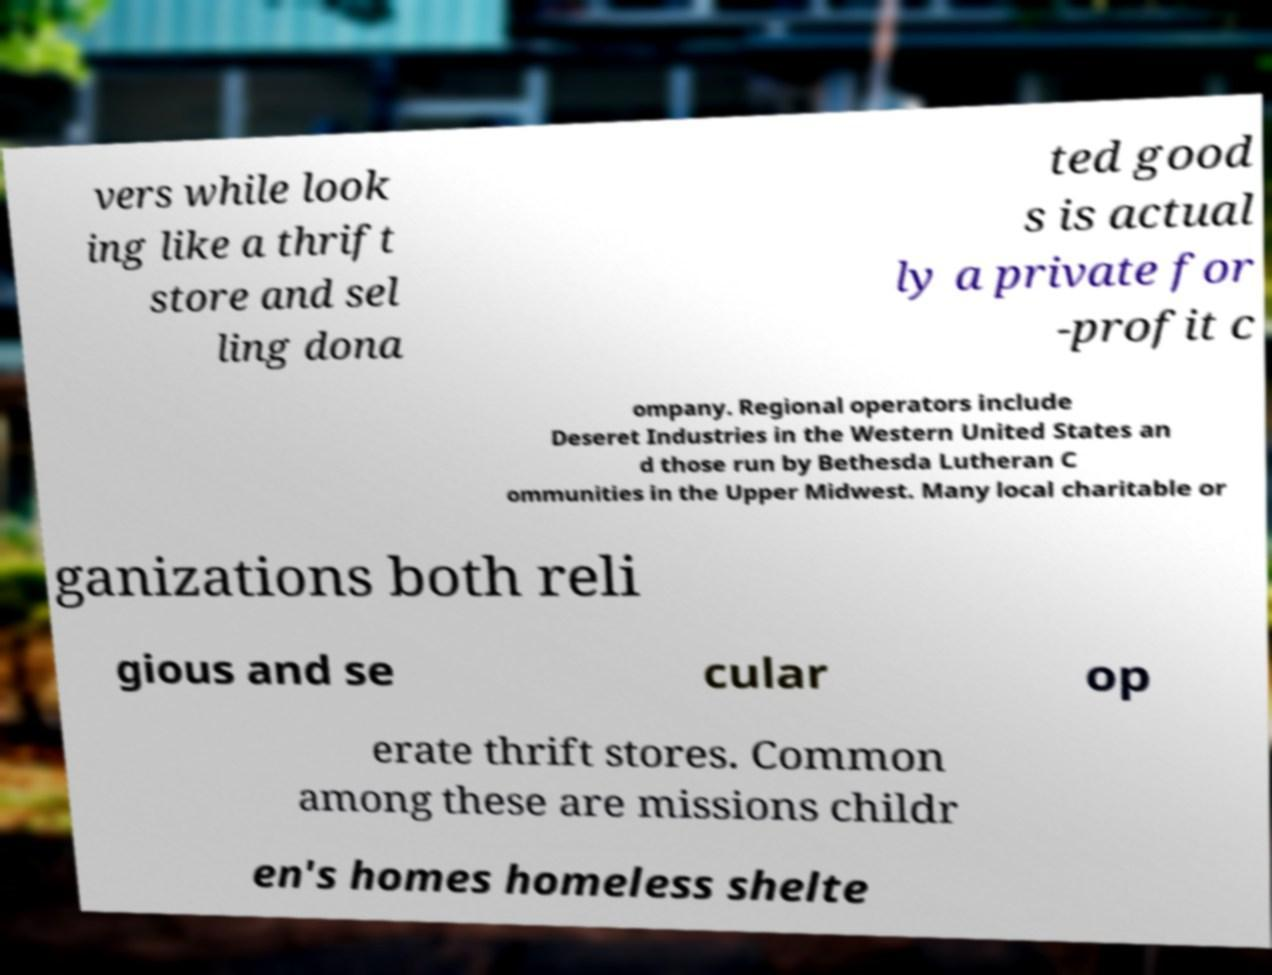For documentation purposes, I need the text within this image transcribed. Could you provide that? vers while look ing like a thrift store and sel ling dona ted good s is actual ly a private for -profit c ompany. Regional operators include Deseret Industries in the Western United States an d those run by Bethesda Lutheran C ommunities in the Upper Midwest. Many local charitable or ganizations both reli gious and se cular op erate thrift stores. Common among these are missions childr en's homes homeless shelte 